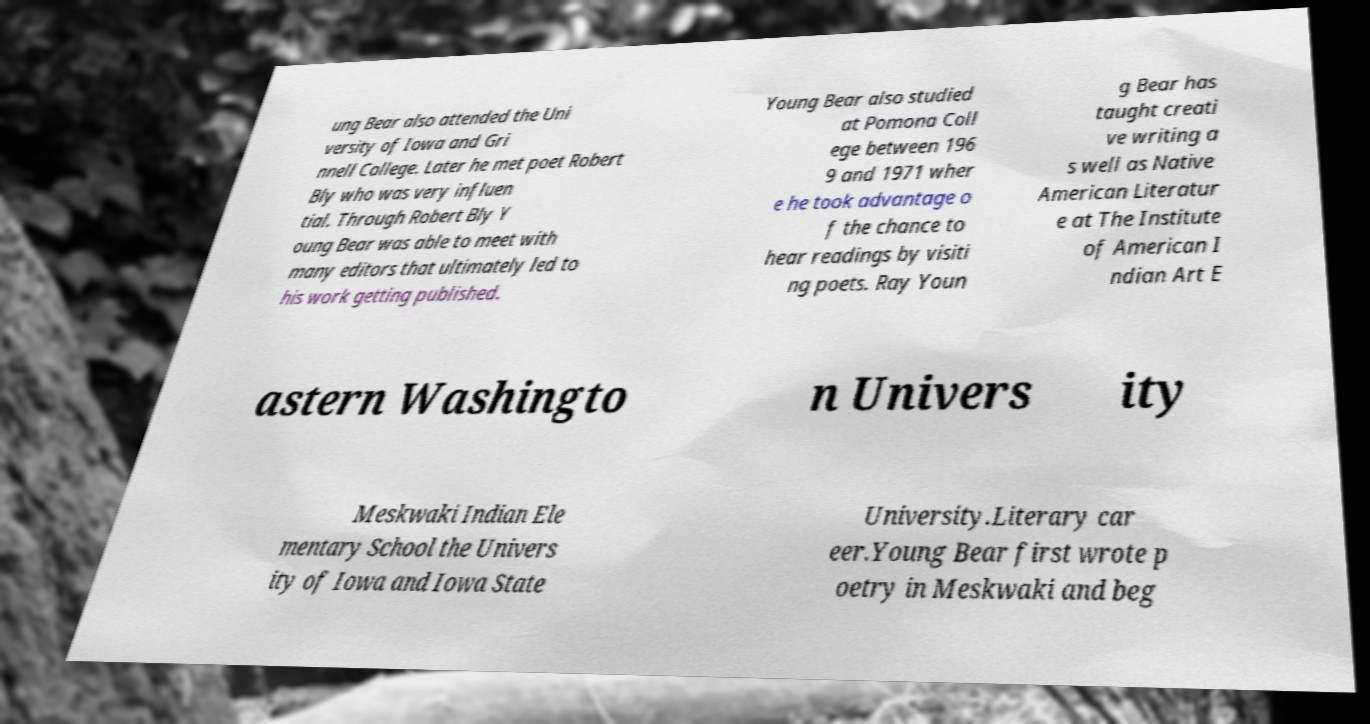I need the written content from this picture converted into text. Can you do that? ung Bear also attended the Uni versity of Iowa and Gri nnell College. Later he met poet Robert Bly who was very influen tial. Through Robert Bly Y oung Bear was able to meet with many editors that ultimately led to his work getting published. Young Bear also studied at Pomona Coll ege between 196 9 and 1971 wher e he took advantage o f the chance to hear readings by visiti ng poets. Ray Youn g Bear has taught creati ve writing a s well as Native American Literatur e at The Institute of American I ndian Art E astern Washingto n Univers ity Meskwaki Indian Ele mentary School the Univers ity of Iowa and Iowa State University.Literary car eer.Young Bear first wrote p oetry in Meskwaki and beg 